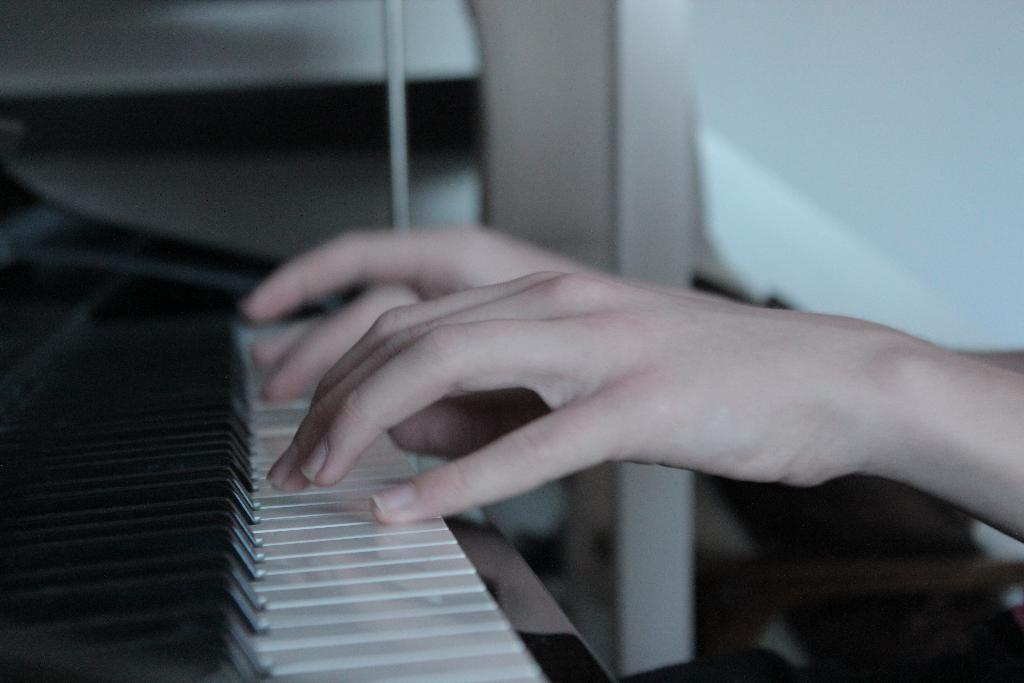What is the main subject of the image? There is a person in the image. What activity is the person engaged in? The person is playing a piano. Can you tell me how many jellyfish are swimming in the background of the image? There are no jellyfish present in the image; it features a person playing a piano. What type of behavior is exhibited by the jellyfish in the image? There are no jellyfish present in the image, so it is not possible to describe their behavior. 